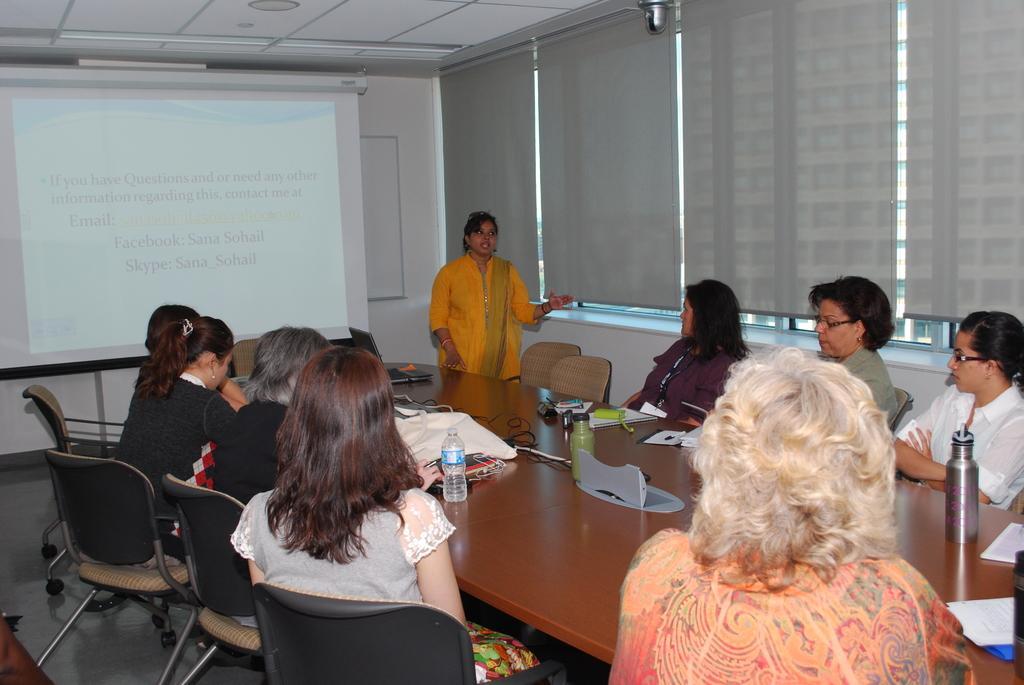Could you give a brief overview of what you see in this image? There are few women in the room. A woman wearing a yellow dress is standing and addressing the crowd. There is a table, a projector board and few chairs in the image. There is a laptop on the table. There are also bottles, paper, bags and few other things on table. There is text displayed on the projector board. 